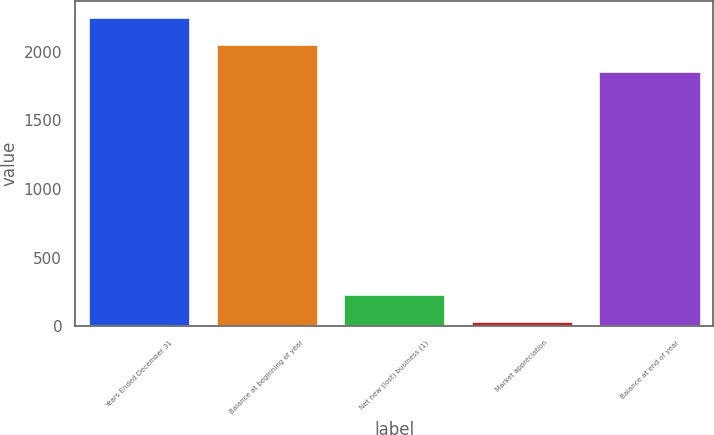Convert chart. <chart><loc_0><loc_0><loc_500><loc_500><bar_chart><fcel>Years Ended December 31<fcel>Balance at beginning of year<fcel>Net new (lost) business (1)<fcel>Market appreciation<fcel>Balance at end of year<nl><fcel>2253.2<fcel>2055.6<fcel>232.6<fcel>35<fcel>1858<nl></chart> 